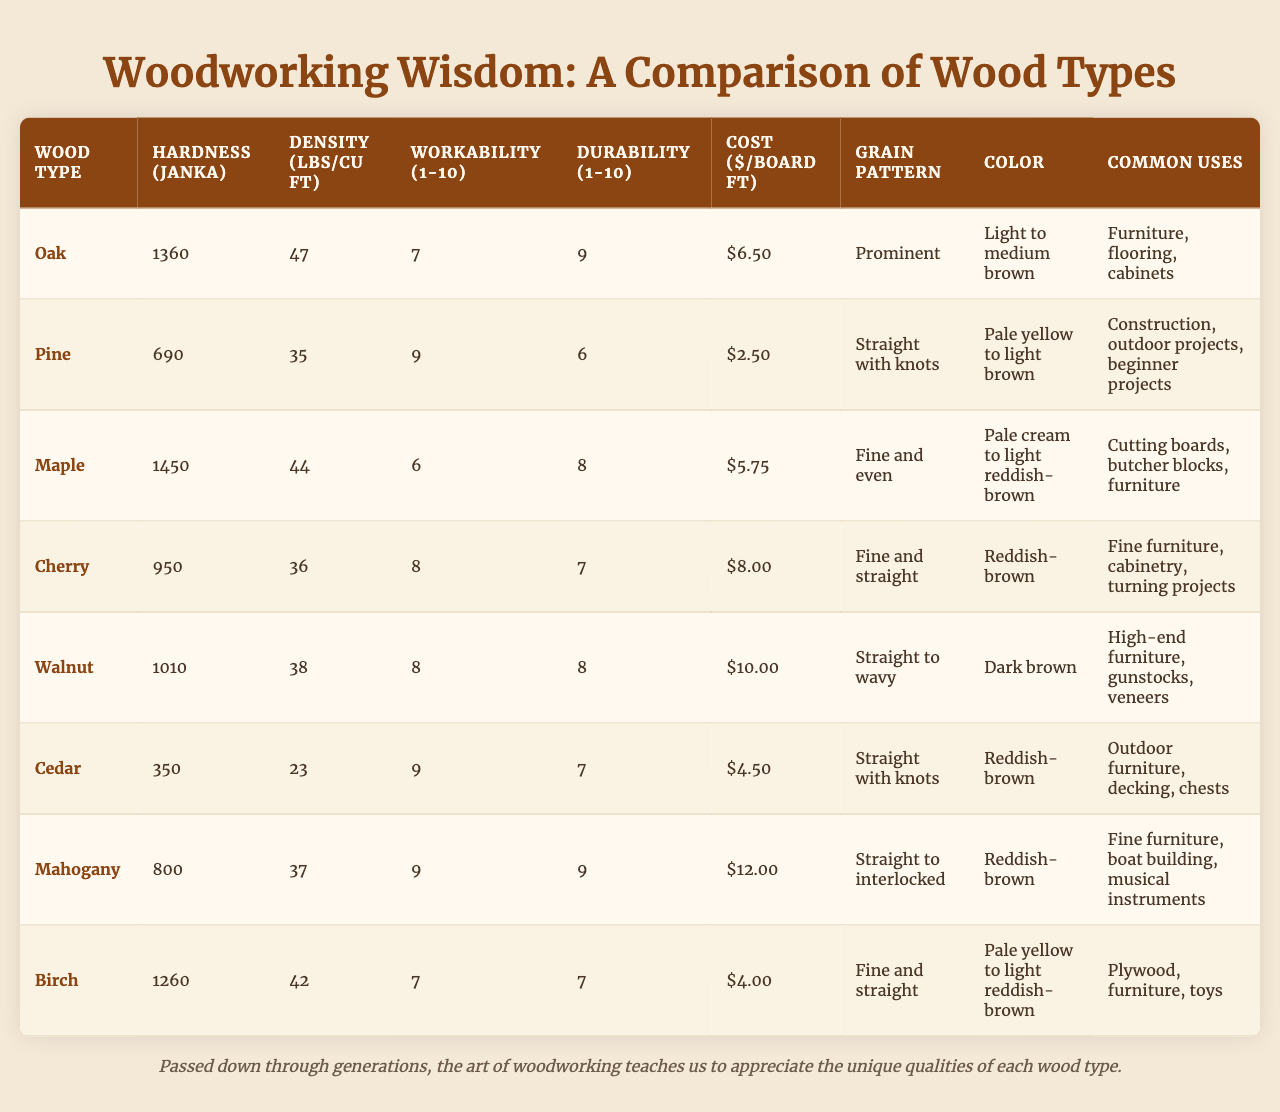What is the hardest wood type listed in the table? According to the Janka hardness values in the table, Oak has the highest hardness at 1360.
Answer: Oak Which wood type has the lowest density? The density values show that Cedar has the lowest density at 23 lbs/cu ft.
Answer: Cedar What is the average cost of the wood types listed? The total cost of all wood types is (6.50 + 2.50 + 5.75 + 8.00 + 10.00 + 4.50 + 12.00 + 4.00) = 53.25, and there are 8 wood types, so the average cost is 53.25 / 8 = 6.66.
Answer: 6.66 Is Pine the most durable wood type? The durability scores indicate that Pine has a durability of 6, which is not the highest; Oak and Mahogany both have a durability score of 9.
Answer: No What is the color of Maple wood? The table states that Maple wood color ranges from pale cream to light reddish-brown.
Answer: Pale cream to light reddish-brown Which wood type is commonly used for high-end furniture? The table shows that Walnut is specified as commonly used for high-end furniture.
Answer: Walnut How does the cost of Cedar compare to the cost of Mahogany? Cedar costs $4.50, while Mahogany costs $12.00. The difference is 12.00 - 4.50 = 7.50, meaning Cedar is cheaper by $7.50.
Answer: Cedar is cheaper by $7.50 Which wood type has the best workability rating? The table shows that Pine and Mahogany both have the highest workability rating at 9.
Answer: Pine and Mahogany What wood type has a prominent grain pattern and is commonly used in flooring? The data reveals that Oak has a prominent grain pattern and is commonly used in flooring.
Answer: Oak If you were to choose a wood type for outdoor projects based on durability, which would you pick? For outdoor projects, Cedar has a durability rating of 7, which is acceptable, while Pine has a lower durability of 6. Comparing these, Cedar is the better choice.
Answer: Cedar 